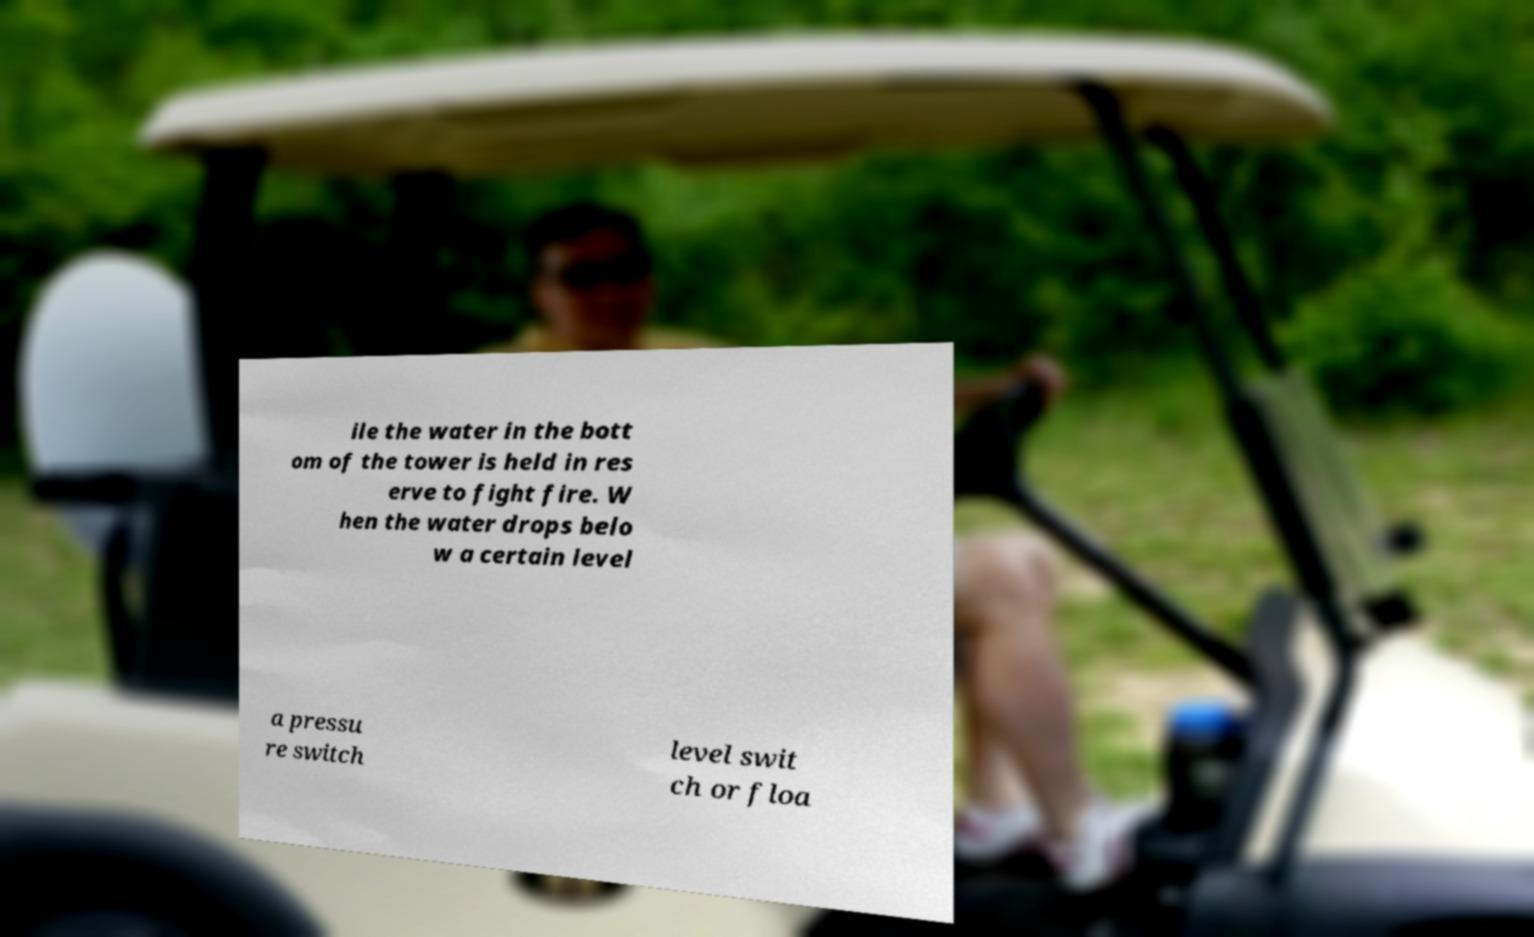For documentation purposes, I need the text within this image transcribed. Could you provide that? ile the water in the bott om of the tower is held in res erve to fight fire. W hen the water drops belo w a certain level a pressu re switch level swit ch or floa 